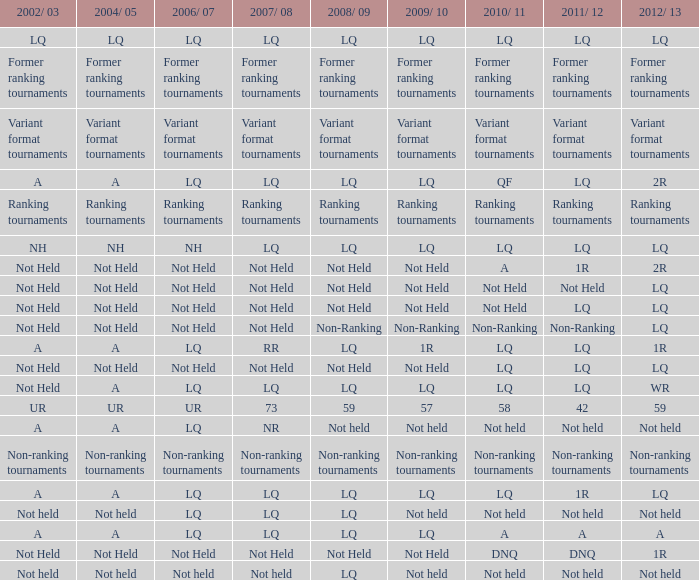Name the 2008/09 with 2004/05 of ranking tournaments Ranking tournaments. 